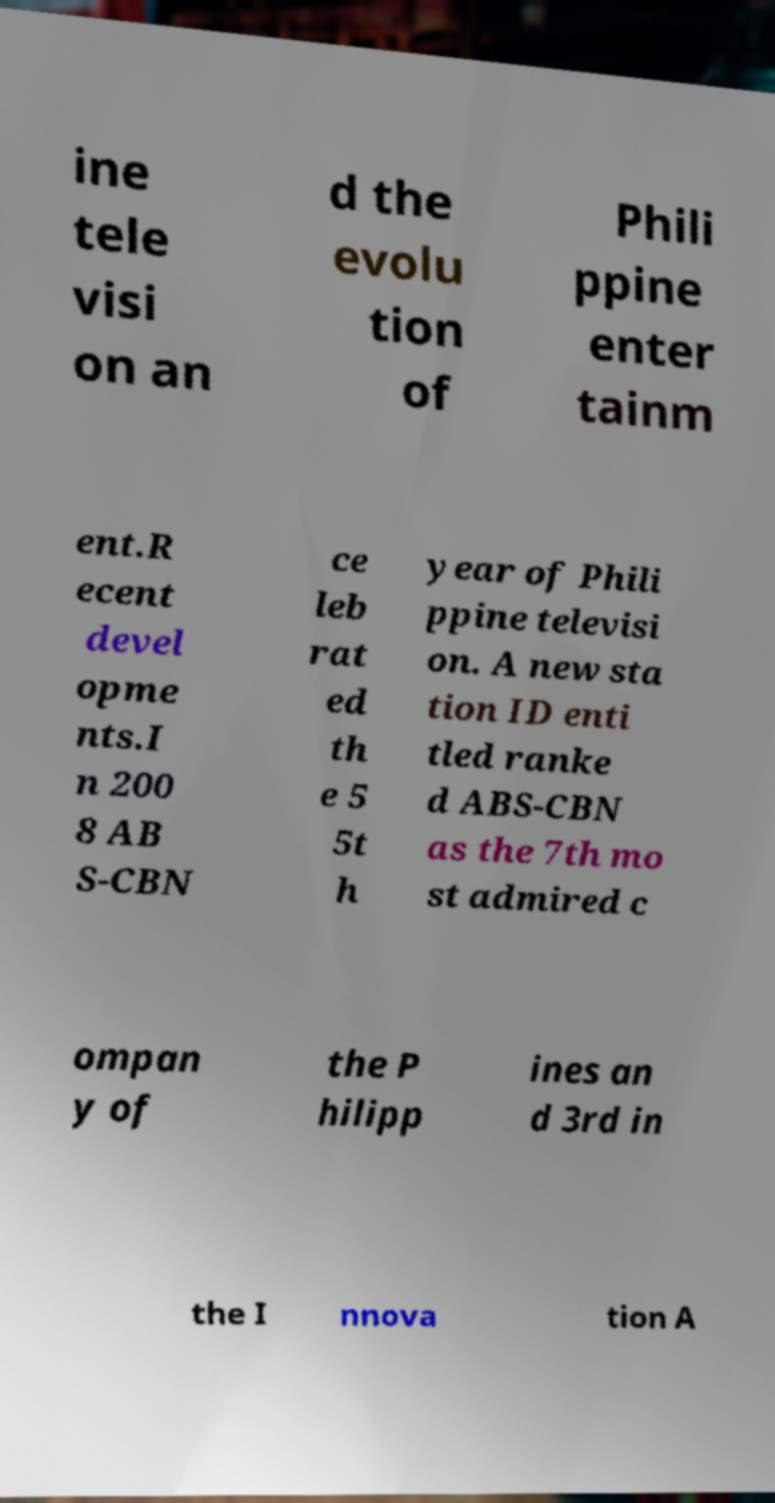Could you extract and type out the text from this image? ine tele visi on an d the evolu tion of Phili ppine enter tainm ent.R ecent devel opme nts.I n 200 8 AB S-CBN ce leb rat ed th e 5 5t h year of Phili ppine televisi on. A new sta tion ID enti tled ranke d ABS-CBN as the 7th mo st admired c ompan y of the P hilipp ines an d 3rd in the I nnova tion A 